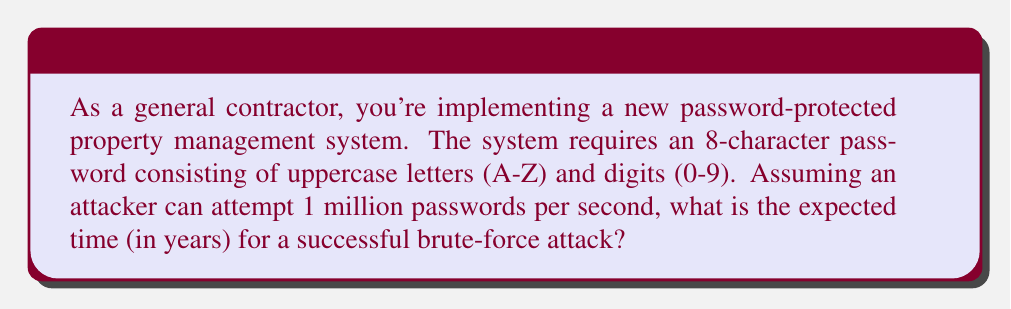Give your solution to this math problem. Let's approach this step-by-step:

1) First, we need to calculate the total number of possible passwords:
   - There are 26 uppercase letters and 10 digits, so 36 possible characters for each position.
   - The password is 8 characters long.
   - Total number of possibilities: $36^8$

2) Calculate the total number of possibilities:
   $$ N = 36^8 = 2,821,109,907,456 $$

3) Now, let's consider the attack rate:
   - The attacker can try 1 million ($$10^6$$) passwords per second.

4) To find the expected time, we divide the total number of possibilities by the attack rate:
   $$ T = \frac{2,821,109,907,456}{10^6} \text{ seconds} $$

5) Simplify:
   $$ T = 2,821,109.907456 \text{ seconds} $$

6) Convert to years:
   $$ T = \frac{2,821,109.907456}{60 \times 60 \times 24 \times 365.25} \text{ years} $$

7) Calculate:
   $$ T \approx 0.0894 \text{ years} $$

Therefore, the expected time for a successful brute-force attack is approximately 0.0894 years, or about 32.6 days.
Answer: 0.0894 years 